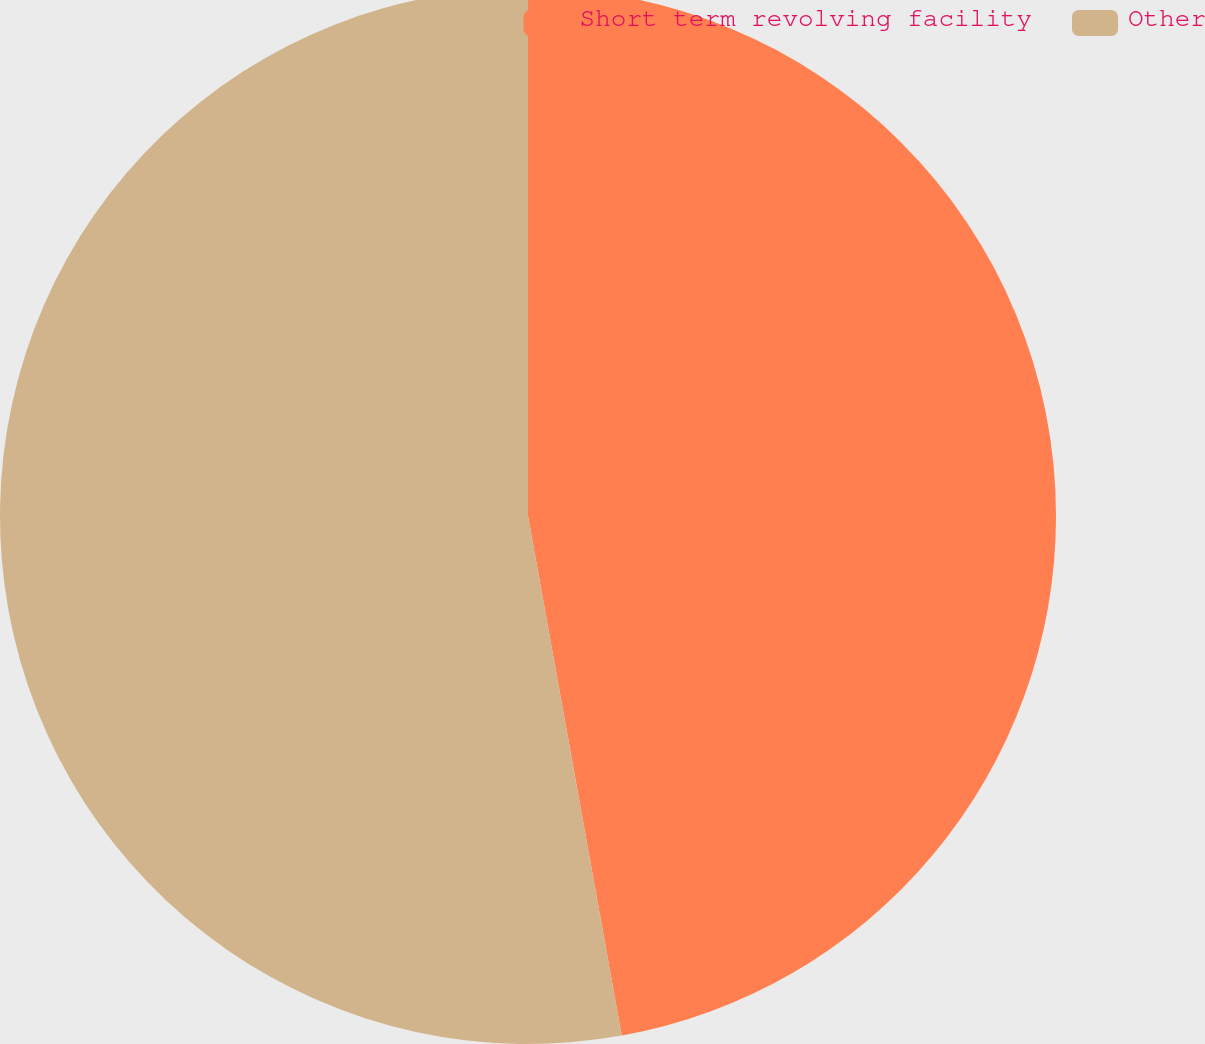Convert chart. <chart><loc_0><loc_0><loc_500><loc_500><pie_chart><fcel>Short term revolving facility<fcel>Other<nl><fcel>47.16%<fcel>52.84%<nl></chart> 